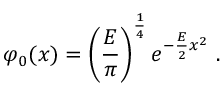<formula> <loc_0><loc_0><loc_500><loc_500>\varphi _ { 0 } ( x ) = \left ( \frac { E } { \pi } \right ) ^ { \frac { 1 } { 4 } } e ^ { - \frac { E } { 2 } x ^ { 2 } } \, .</formula> 